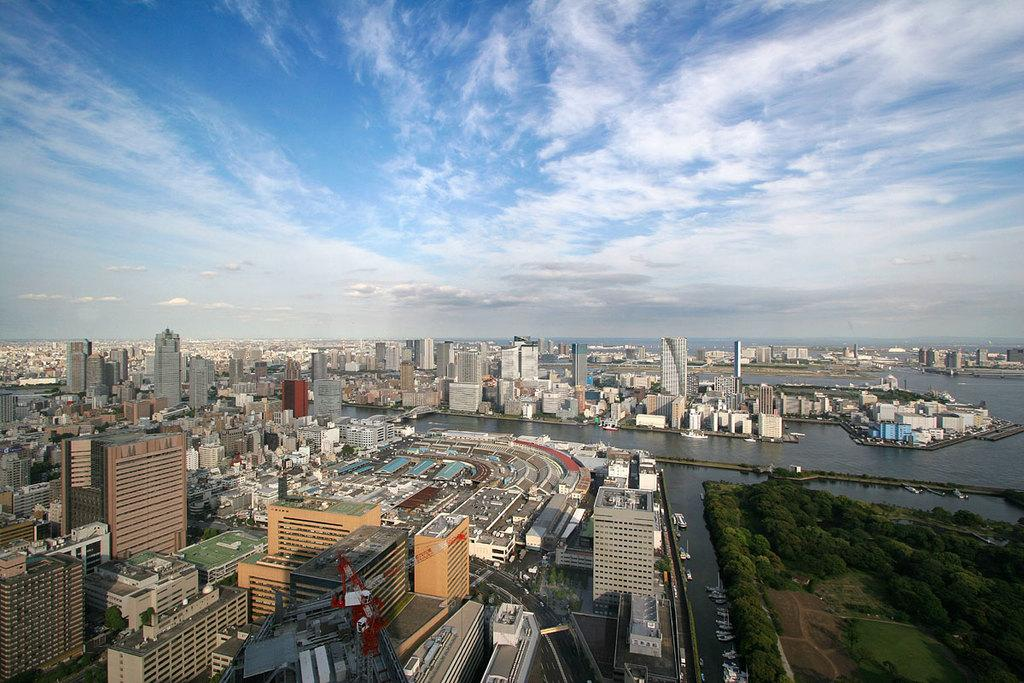What type of structures can be seen in the image? There are buildings in the image. What type of vegetation is visible in the image? There is grass and plants visible in the image. What is the condition of the water in the image? There is water with objects floating on it in the image. What part of the natural environment is visible in the image? The sky is visible in the image. What can be seen in the sky in the image? Clouds are present in the sky. How does the window in the image aid in the digestion process? There is no window present in the image, and therefore it cannot aid in any digestion process. What type of bell can be seen ringing in the image? There is no bell present in the image. 